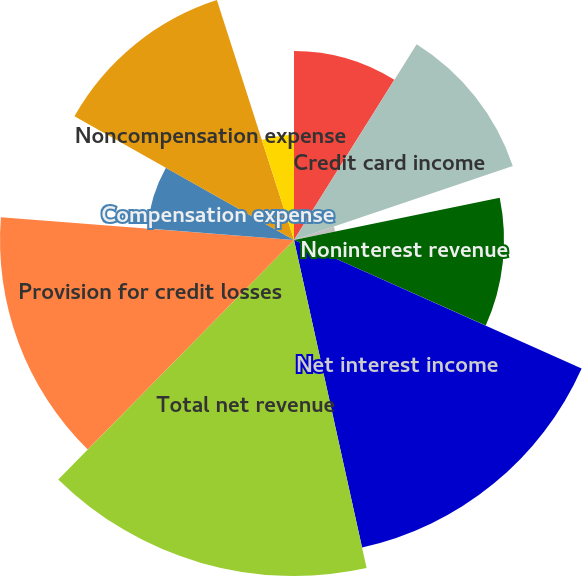Convert chart. <chart><loc_0><loc_0><loc_500><loc_500><pie_chart><fcel>Year ended December 31 (in<fcel>Credit card income<fcel>All other income<fcel>Noninterest revenue<fcel>Net interest income<fcel>Total net revenue<fcel>Provision for credit losses<fcel>Compensation expense<fcel>Noncompensation expense<fcel>Amortization of intangibles<nl><fcel>8.91%<fcel>10.89%<fcel>1.98%<fcel>9.9%<fcel>14.85%<fcel>15.84%<fcel>13.86%<fcel>6.93%<fcel>11.88%<fcel>4.95%<nl></chart> 